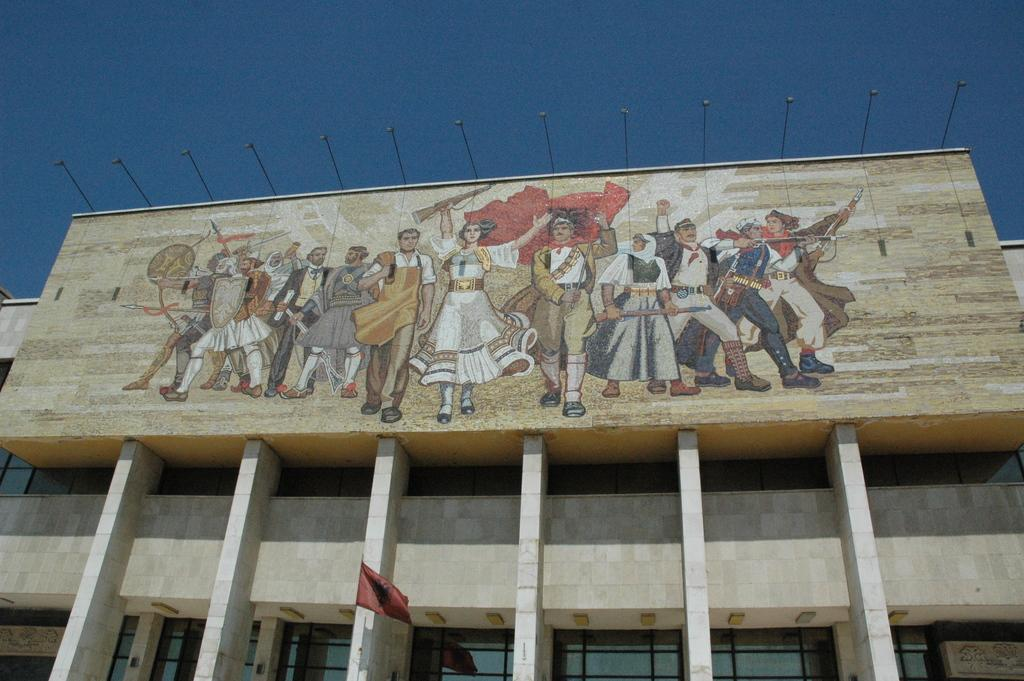What is hanging on the wall in the image? There is a painting on the wall in the image. What architectural features can be seen in the image? There are pillars in the image. What type of illumination is present in the image? There are lights in the image. What symbol can be seen in the image? There is a flag in the image. What can be seen in the background of the image? The sky is visible in the background of the image. What is the color of the sky in the image? The color of the sky is blue. What type of chalk is being used to draw on the pillars in the image? There is no chalk or drawing on the pillars in the image; the pillars are simply architectural features. How does the flag stretch across the sky in the image? The flag does not stretch across the sky in the image; it is a separate object hanging or standing in the scene. 